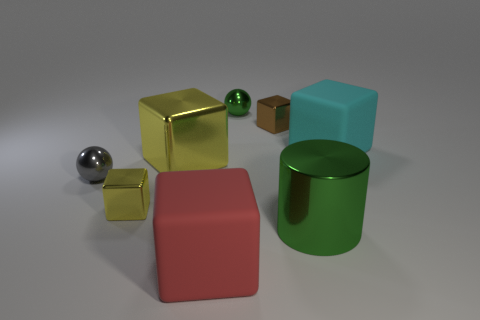Can you tell me what colors the objects in the image are and which one appears to be the largest? Certainly! In the image, there is a variety of colored objects including a yellow metallic cube, a red matte cube, a cyan rubber-looking cube, a green metallic cylinder, and a smaller silver metallic sphere. As for size, the yellow metallic cube appears to be the largest object present. Do the shapes in the image have any particular orientation or arrangement? The shapes are arranged without a specific pattern on an even surface. They are oriented in different directions, providing a view of their various geometrical features and reflections, suggesting an arbitrary or casual placement. 